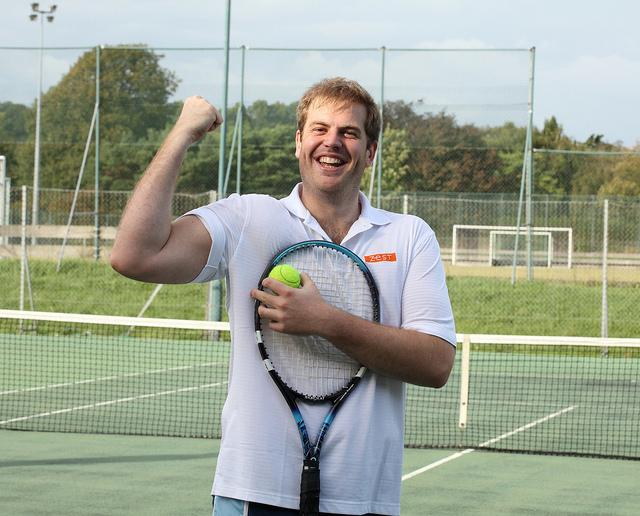What does the man show off here?

Choices:
A) racquet
B) tennis ball
C) shirt
D) bicep bicep 